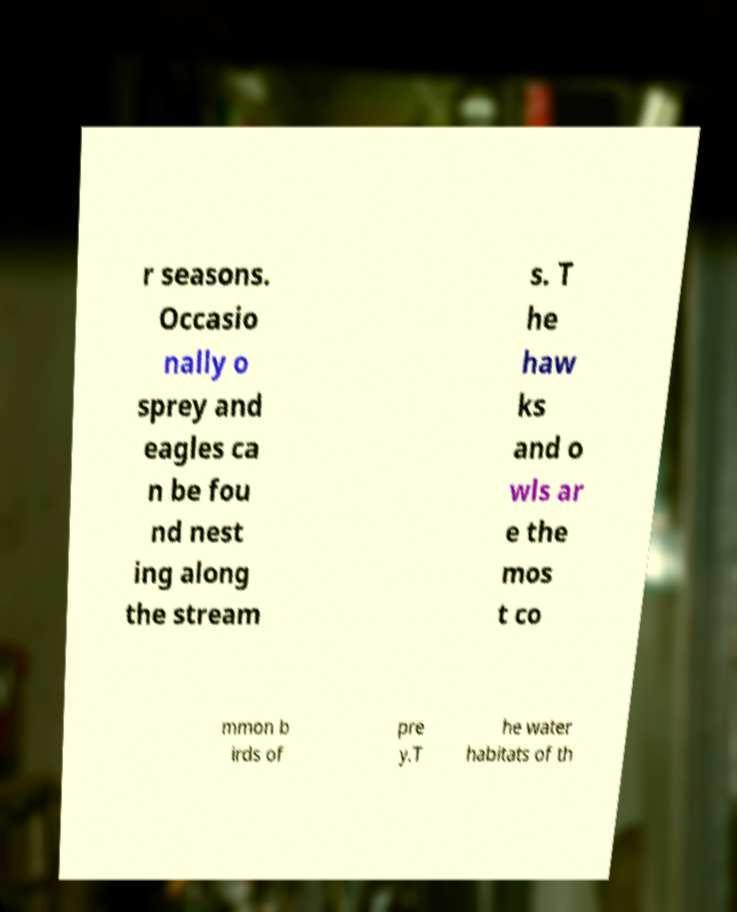Can you accurately transcribe the text from the provided image for me? r seasons. Occasio nally o sprey and eagles ca n be fou nd nest ing along the stream s. T he haw ks and o wls ar e the mos t co mmon b irds of pre y.T he water habitats of th 